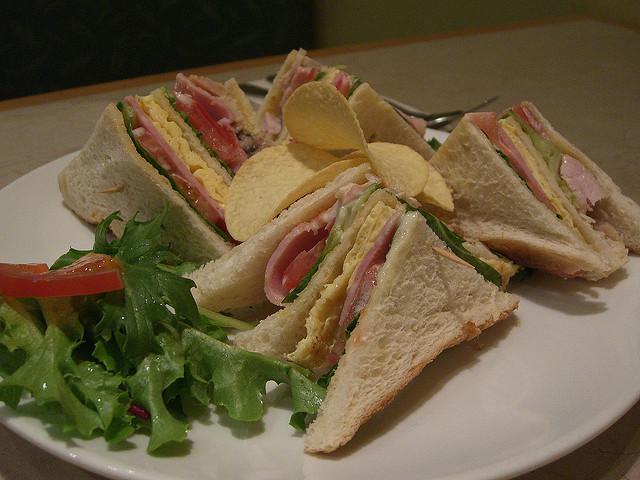What is the sandwich resting on?
Be succinct. Plate. Is this a bagel sandwich?
Concise answer only. No. Why is the bread not toasted?
Give a very brief answer. Cold sandwich. What is on the sandwiches?
Quick response, please. Chips. What sandwich is on the plate?
Be succinct. Club. Could the bread be toasted?
Quick response, please. No. Is there a glass on the table?
Give a very brief answer. No. What are these green things?
Answer briefly. Lettuce. Is this a vegetarian meal?
Answer briefly. No. What meat is on the sandwich?
Be succinct. Ham. Are there tomatoes on this sandwich?
Write a very short answer. Yes. Could that be rye?
Keep it brief. No. Is the salad good?
Concise answer only. Yes. Is that a salad or a hamburger?
Give a very brief answer. Salad. Is there a tomato on the plate?
Be succinct. Yes. What food is next to the sandwich?
Give a very brief answer. Salad. What is on the left side of the bread?
Concise answer only. Salad. What kind of bread is used in this sandwich?
Be succinct. White. Are all the sandwiches the same?
Quick response, please. Yes. 